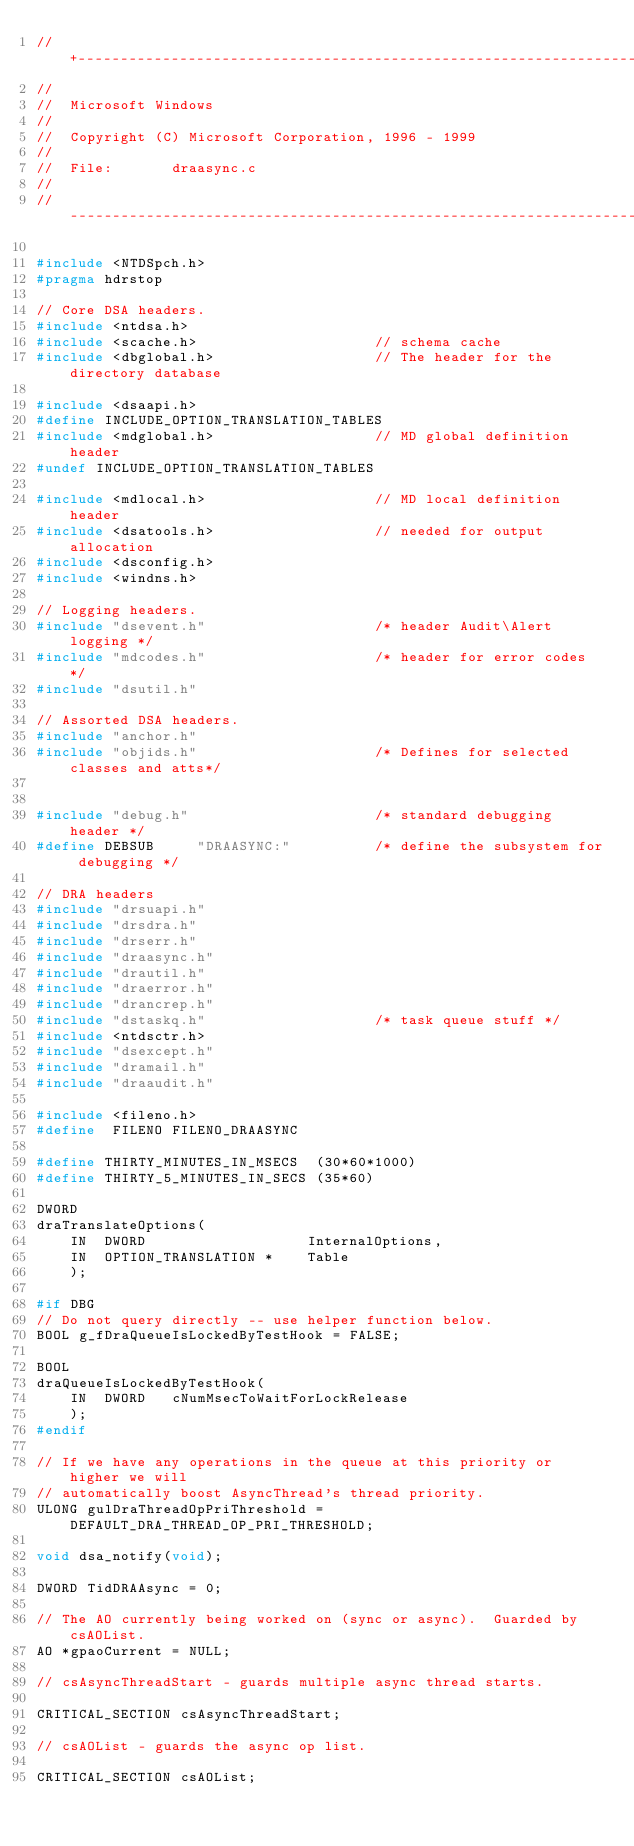<code> <loc_0><loc_0><loc_500><loc_500><_C_>//+-------------------------------------------------------------------------
//
//  Microsoft Windows
//
//  Copyright (C) Microsoft Corporation, 1996 - 1999
//
//  File:       draasync.c
//
//--------------------------------------------------------------------------

#include <NTDSpch.h>
#pragma hdrstop

// Core DSA headers.
#include <ntdsa.h>
#include <scache.h>                     // schema cache
#include <dbglobal.h>                   // The header for the directory database

#include <dsaapi.h>
#define INCLUDE_OPTION_TRANSLATION_TABLES
#include <mdglobal.h>                   // MD global definition header
#undef INCLUDE_OPTION_TRANSLATION_TABLES

#include <mdlocal.h>                    // MD local definition header
#include <dsatools.h>                   // needed for output allocation
#include <dsconfig.h>
#include <windns.h>

// Logging headers.
#include "dsevent.h"                    /* header Audit\Alert logging */
#include "mdcodes.h"                    /* header for error codes */
#include "dsutil.h"

// Assorted DSA headers.
#include "anchor.h"
#include "objids.h"                     /* Defines for selected classes and atts*/


#include "debug.h"                      /* standard debugging header */
#define DEBSUB     "DRAASYNC:"          /* define the subsystem for debugging */

// DRA headers
#include "drsuapi.h"
#include "drsdra.h"
#include "drserr.h"
#include "draasync.h"
#include "drautil.h"
#include "draerror.h"
#include "drancrep.h"
#include "dstaskq.h"                    /* task queue stuff */
#include <ntdsctr.h>
#include "dsexcept.h"
#include "dramail.h"
#include "draaudit.h"

#include <fileno.h>
#define  FILENO FILENO_DRAASYNC

#define THIRTY_MINUTES_IN_MSECS  (30*60*1000)
#define THIRTY_5_MINUTES_IN_SECS (35*60)

DWORD
draTranslateOptions(
    IN  DWORD                   InternalOptions,
    IN  OPTION_TRANSLATION *    Table
    );

#if DBG
// Do not query directly -- use helper function below.
BOOL g_fDraQueueIsLockedByTestHook = FALSE;

BOOL
draQueueIsLockedByTestHook(
    IN  DWORD   cNumMsecToWaitForLockRelease
    );
#endif

// If we have any operations in the queue at this priority or higher we will
// automatically boost AsyncThread's thread priority.
ULONG gulDraThreadOpPriThreshold = DEFAULT_DRA_THREAD_OP_PRI_THRESHOLD;

void dsa_notify(void);

DWORD TidDRAAsync = 0;

// The AO currently being worked on (sync or async).  Guarded by csAOList.
AO *gpaoCurrent = NULL;

// csAsyncThreadStart - guards multiple async thread starts.

CRITICAL_SECTION csAsyncThreadStart;

// csAOList - guards the async op list.

CRITICAL_SECTION csAOList;
</code> 